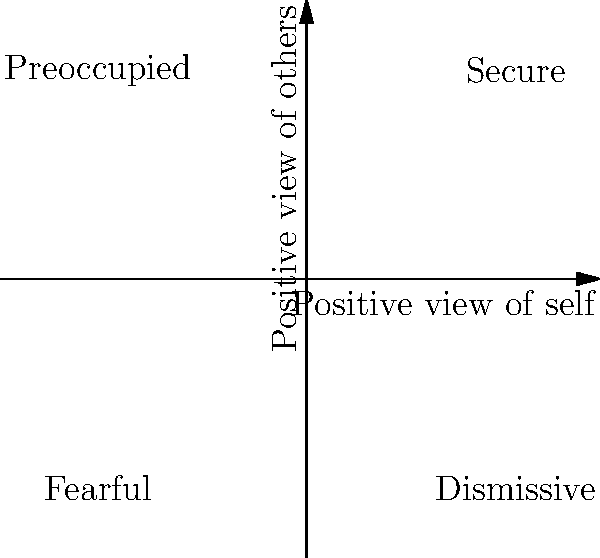Based on the attachment style quadrant diagram, which attachment style is characterized by a negative view of self and a positive view of others? To answer this question, we need to analyze the quadrant diagram of attachment styles:

1. The diagram is divided into four quadrants by two axes:
   - The horizontal axis represents the "Positive view of self"
   - The vertical axis represents the "Positive view of others"

2. Each quadrant represents a different attachment style:
   - Top-right: Secure (positive view of self and others)
   - Top-left: Preoccupied
   - Bottom-right: Dismissive
   - Bottom-left: Fearful

3. The question asks for an attachment style with a negative view of self and a positive view of others:
   - Negative view of self: Left side of the vertical axis
   - Positive view of others: Upper half of the horizontal axis

4. Examining the quadrants, we find that the top-left quadrant meets both criteria:
   - It's on the left side (negative view of self)
   - It's in the upper half (positive view of others)

5. The attachment style in the top-left quadrant is labeled as "Preoccupied"

Therefore, the attachment style characterized by a negative view of self and a positive view of others is the Preoccupied attachment style.
Answer: Preoccupied attachment style 